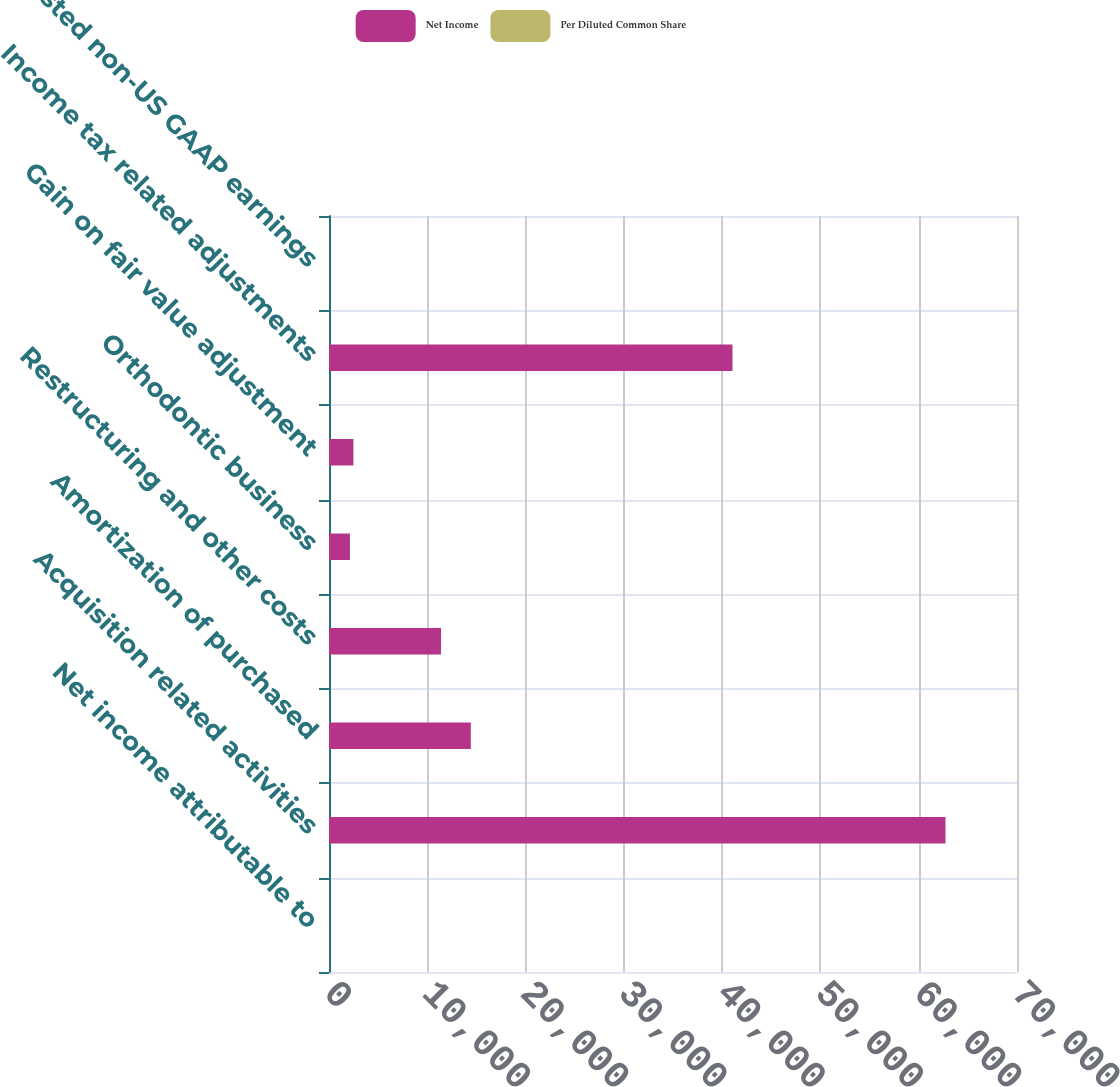Convert chart to OTSL. <chart><loc_0><loc_0><loc_500><loc_500><stacked_bar_chart><ecel><fcel>Net income attributable to<fcel>Acquisition related activities<fcel>Amortization of purchased<fcel>Restructuring and other costs<fcel>Orthodontic business<fcel>Gain on fair value adjustment<fcel>Income tax related adjustments<fcel>Adjusted non-US GAAP earnings<nl><fcel>Net Income<fcel>1.865<fcel>62723<fcel>14428<fcel>11395<fcel>2128<fcel>2486<fcel>41053<fcel>1.865<nl><fcel>Per Diluted Common Share<fcel>1.7<fcel>0.44<fcel>0.1<fcel>0.08<fcel>0.01<fcel>0.02<fcel>0.28<fcel>2.03<nl></chart> 